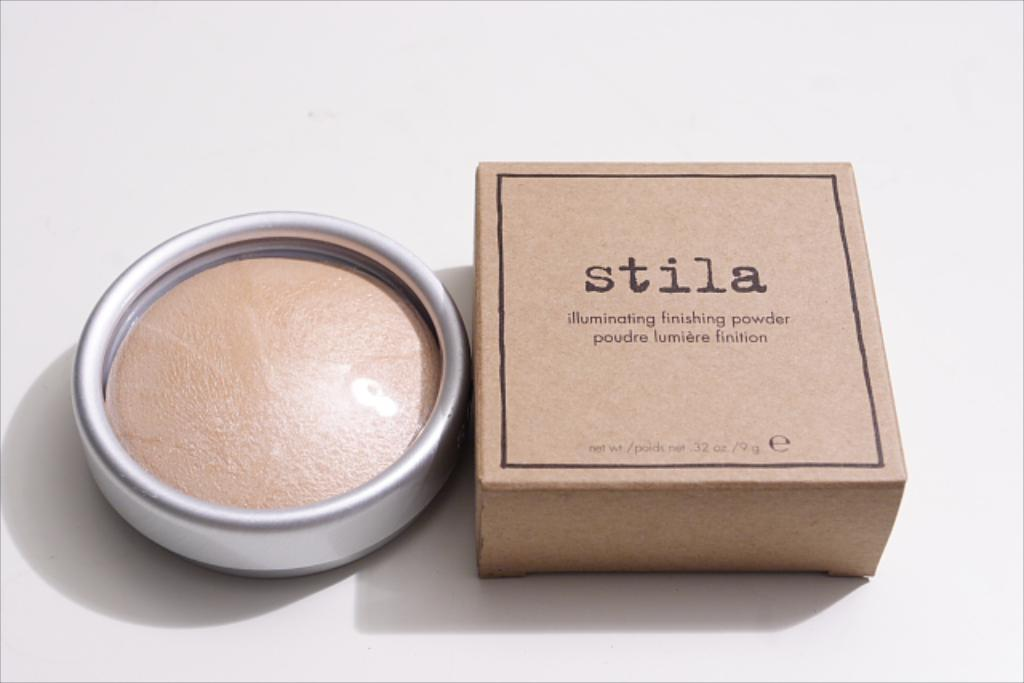Provide a one-sentence caption for the provided image. A box and jar of Stila illuminating finishing powder. 